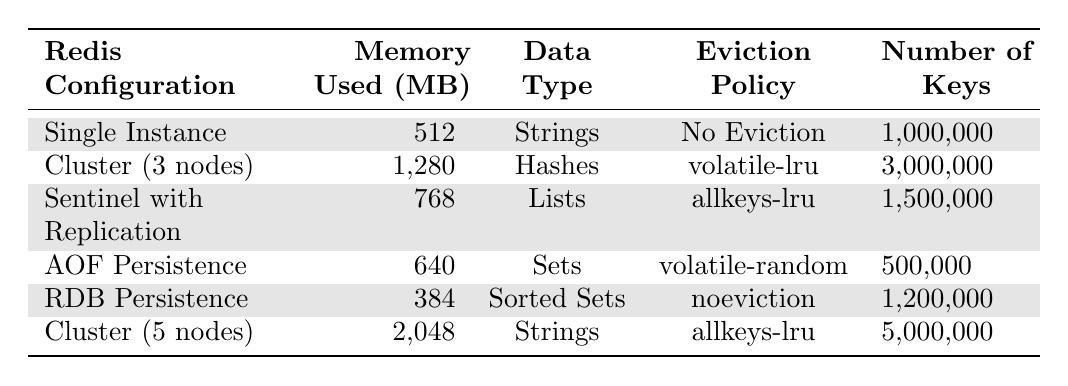What is the memory usage of the Redis Cluster with 3 nodes? It is directly listed in the table under the "Memory Used (MB)" column for the "Cluster (3 nodes)" configuration, which states 1280 MB.
Answer: 1280 MB How many keys are used in Redis with AOF Persistence? In the table, the row for "AOF Persistence" shows under "Number of Keys," it has a total of 500,000 keys.
Answer: 500,000 keys Which configuration has the highest memory usage? The "Cluster (5 nodes)" configuration has the highest memory usage of 2048 MB as seen in the table.
Answer: Cluster (5 nodes) What is the average memory usage of all listed Redis configurations? First, sum up all memory usages: 512 + 1280 + 768 + 640 + 384 + 2048 = 4532 MB. Then, divide by the number of configurations (6), giving an average of 4532/6 = 755.33 MB.
Answer: 755.33 MB Is the eviction policy for Redis Single Instance "volatile-lru"? According to the table, the eviction policy for "Redis Single Instance" is "No Eviction," so this statement is false.
Answer: No Which data type is used in the configuration with the lowest memory usage? The configuration with the lowest memory usage is "Redis with RDB Persistence" at 384 MB, which uses "Sorted Sets" as its data type according to the table.
Answer: Sorted Sets How many more keys can the Redis Cluster (5 nodes) hold compared to the Redis Single Instance? The Redis Cluster (5 nodes) can hold 5,000,000 keys, while the Redis Single Instance holds 1,000,000 keys. The difference is 5,000,000 - 1,000,000 = 4,000,000 keys.
Answer: 4,000,000 keys What is the ratio of memory usage between Redis Single Instance and Redis with AOF Persistence? "Redis Single Instance" uses 512 MB and "Redis with AOF Persistence" uses 640 MB. The ratio is 512:640, which simplifies to 8:10 or 4:5.
Answer: 4:5 Does Redis Sentinel with Replication use more or less memory than Redis with RDB Persistence? "Redis Sentinel with Replication" uses 768 MB while "Redis with RDB Persistence" uses 384 MB, so it uses more memory.
Answer: More What is the total memory used by all configurations combined? By adding all memory values: 512 + 1280 + 768 + 640 + 384 + 2048 = 4532 MB, giving a total of 4532 MB.
Answer: 4532 MB 